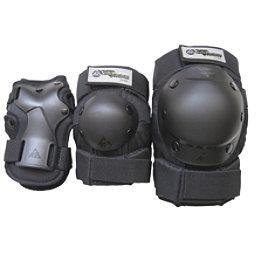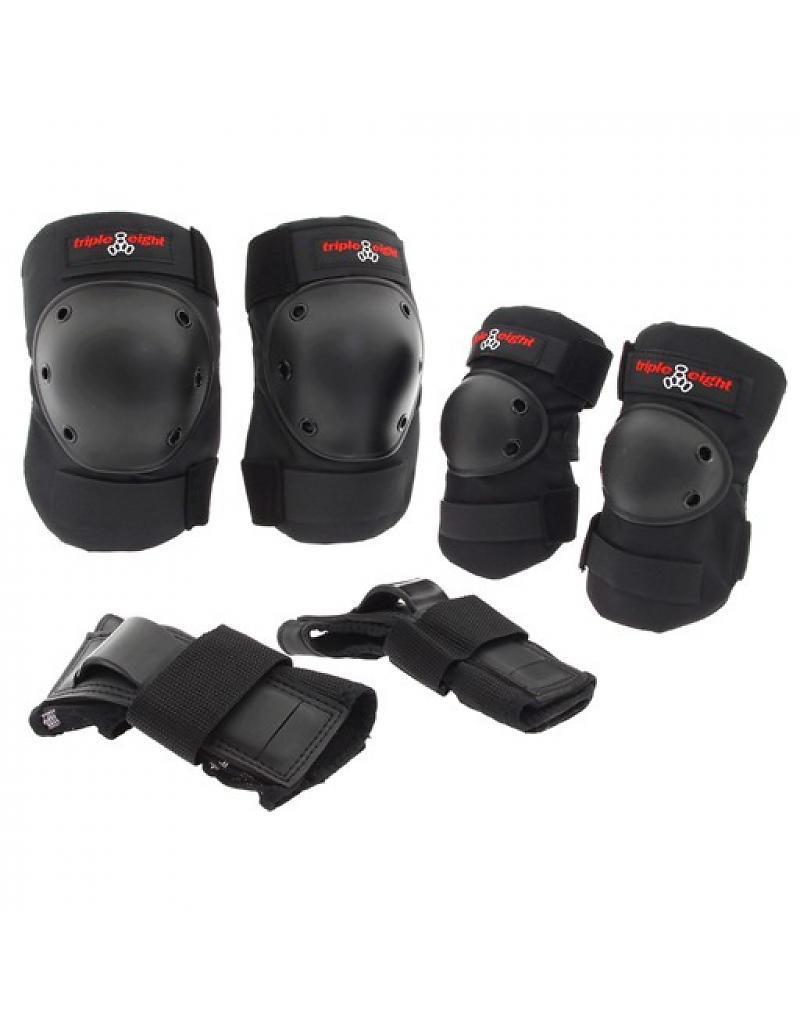The first image is the image on the left, the second image is the image on the right. Considering the images on both sides, is "An image shows a set of three pairs of protective items, which are solid black with red on the logos." valid? Answer yes or no. Yes. The first image is the image on the left, the second image is the image on the right. Examine the images to the left and right. Is the description "Some wrist braces are visible" accurate? Answer yes or no. Yes. 